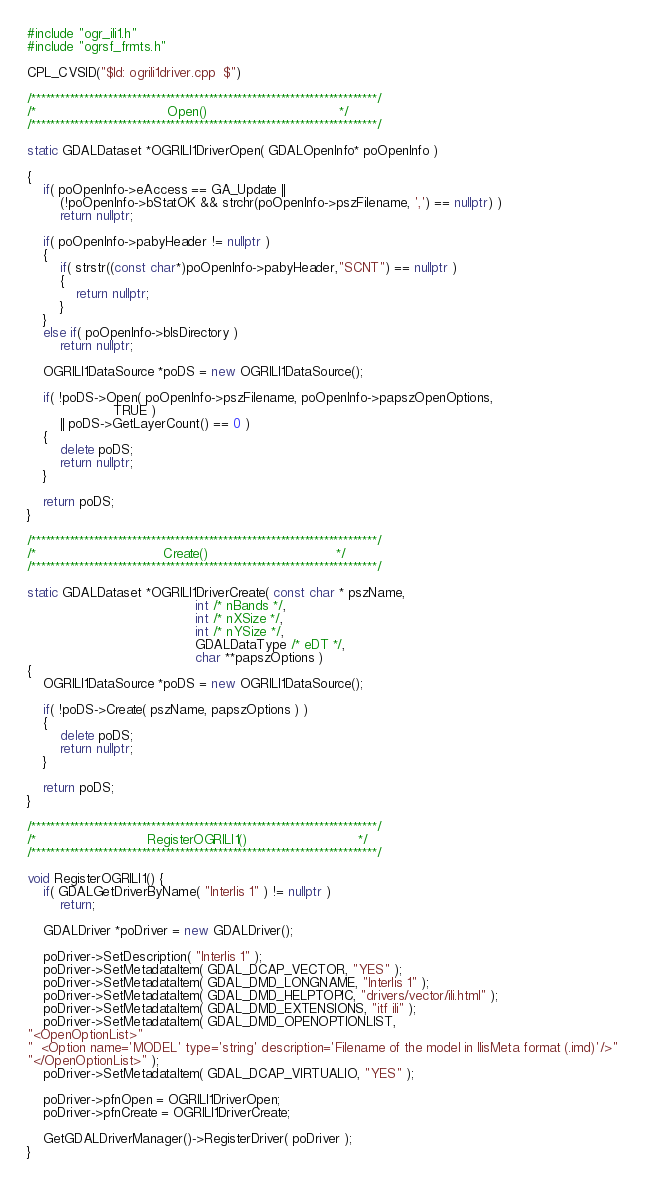Convert code to text. <code><loc_0><loc_0><loc_500><loc_500><_C++_>#include "ogr_ili1.h"
#include "ogrsf_frmts.h"

CPL_CVSID("$Id: ogrili1driver.cpp  $")

/************************************************************************/
/*                                Open()                                */
/************************************************************************/

static GDALDataset *OGRILI1DriverOpen( GDALOpenInfo* poOpenInfo )

{
    if( poOpenInfo->eAccess == GA_Update ||
        (!poOpenInfo->bStatOK && strchr(poOpenInfo->pszFilename, ',') == nullptr) )
        return nullptr;

    if( poOpenInfo->pabyHeader != nullptr )
    {
        if( strstr((const char*)poOpenInfo->pabyHeader,"SCNT") == nullptr )
        {
            return nullptr;
        }
    }
    else if( poOpenInfo->bIsDirectory )
        return nullptr;

    OGRILI1DataSource *poDS = new OGRILI1DataSource();

    if( !poDS->Open( poOpenInfo->pszFilename, poOpenInfo->papszOpenOptions,
                     TRUE )
        || poDS->GetLayerCount() == 0 )
    {
        delete poDS;
        return nullptr;
    }

    return poDS;
}

/************************************************************************/
/*                               Create()                               */
/************************************************************************/

static GDALDataset *OGRILI1DriverCreate( const char * pszName,
                                         int /* nBands */,
                                         int /* nXSize */,
                                         int /* nYSize */,
                                         GDALDataType /* eDT */,
                                         char **papszOptions )
{
    OGRILI1DataSource *poDS = new OGRILI1DataSource();

    if( !poDS->Create( pszName, papszOptions ) )
    {
        delete poDS;
        return nullptr;
    }

    return poDS;
}

/************************************************************************/
/*                           RegisterOGRILI1()                           */
/************************************************************************/

void RegisterOGRILI1() {
    if( GDALGetDriverByName( "Interlis 1" ) != nullptr )
        return;

    GDALDriver *poDriver = new GDALDriver();

    poDriver->SetDescription( "Interlis 1" );
    poDriver->SetMetadataItem( GDAL_DCAP_VECTOR, "YES" );
    poDriver->SetMetadataItem( GDAL_DMD_LONGNAME, "Interlis 1" );
    poDriver->SetMetadataItem( GDAL_DMD_HELPTOPIC, "drivers/vector/ili.html" );
    poDriver->SetMetadataItem( GDAL_DMD_EXTENSIONS, "itf ili" );
    poDriver->SetMetadataItem( GDAL_DMD_OPENOPTIONLIST,
"<OpenOptionList>"
"  <Option name='MODEL' type='string' description='Filename of the model in IlisMeta format (.imd)'/>"
"</OpenOptionList>" );
    poDriver->SetMetadataItem( GDAL_DCAP_VIRTUALIO, "YES" );

    poDriver->pfnOpen = OGRILI1DriverOpen;
    poDriver->pfnCreate = OGRILI1DriverCreate;

    GetGDALDriverManager()->RegisterDriver( poDriver );
}
</code> 